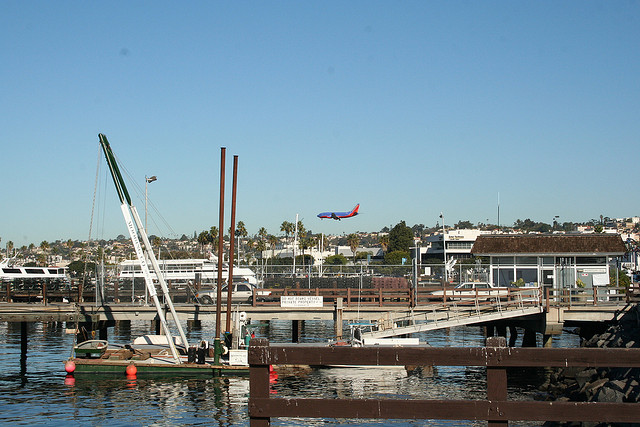What time of day does it appear to be in the image? Judging by the strong light and shadows cast, as well as the brightness of the sky, it appears to be midday. The calm water and lack of activity further suggest it may be a weekday around lunchtime when the area is less busy. 